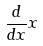Convert formula to latex. <formula><loc_0><loc_0><loc_500><loc_500>\frac { d } { d x } x</formula> 